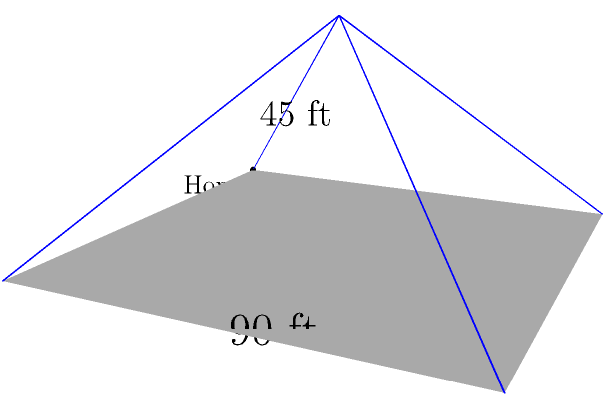Remember Dwight Gooden's incredible pitching from the mound? Now, imagine modeling a baseball diamond as a square pyramid. If each side of the base (the diamond) is 90 feet long, and the height of the pyramid (distance from home plate to the peak above the center of the diamond) is 45 feet, what is the total surface area of this pyramid, including the base? Round your answer to the nearest square foot. Let's approach this step-by-step, recalling the geometry of a square pyramid:

1) The base area:
   Base is a square with side 90 feet.
   $A_{base} = 90^2 = 8100$ sq ft

2) For the lateral faces, we need to find their height (slant height):
   Using the Pythagorean theorem:
   $s^2 = 45^2 + (\frac{90\sqrt{2}}{2})^2$
   $s^2 = 2025 + 4050 = 6075$
   $s = \sqrt{6075} \approx 77.94$ ft

3) Area of each triangular face:
   $A_{face} = \frac{1}{2} \times 90 \times 77.94 = 3507.3$ sq ft

4) Total lateral surface area:
   $A_{lateral} = 4 \times 3507.3 = 14029.2$ sq ft

5) Total surface area:
   $A_{total} = A_{base} + A_{lateral}$
   $A_{total} = 8100 + 14029.2 = 22129.2$ sq ft

6) Rounding to the nearest square foot:
   $A_{total} \approx 22129$ sq ft
Answer: 22129 sq ft 